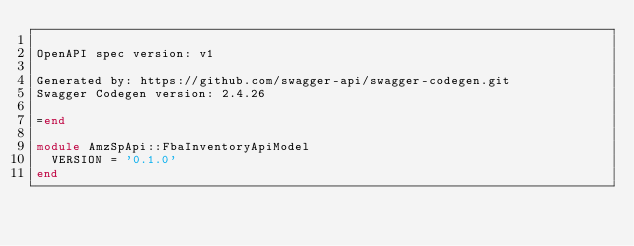Convert code to text. <code><loc_0><loc_0><loc_500><loc_500><_Ruby_>
OpenAPI spec version: v1

Generated by: https://github.com/swagger-api/swagger-codegen.git
Swagger Codegen version: 2.4.26

=end

module AmzSpApi::FbaInventoryApiModel
  VERSION = '0.1.0'
end
</code> 